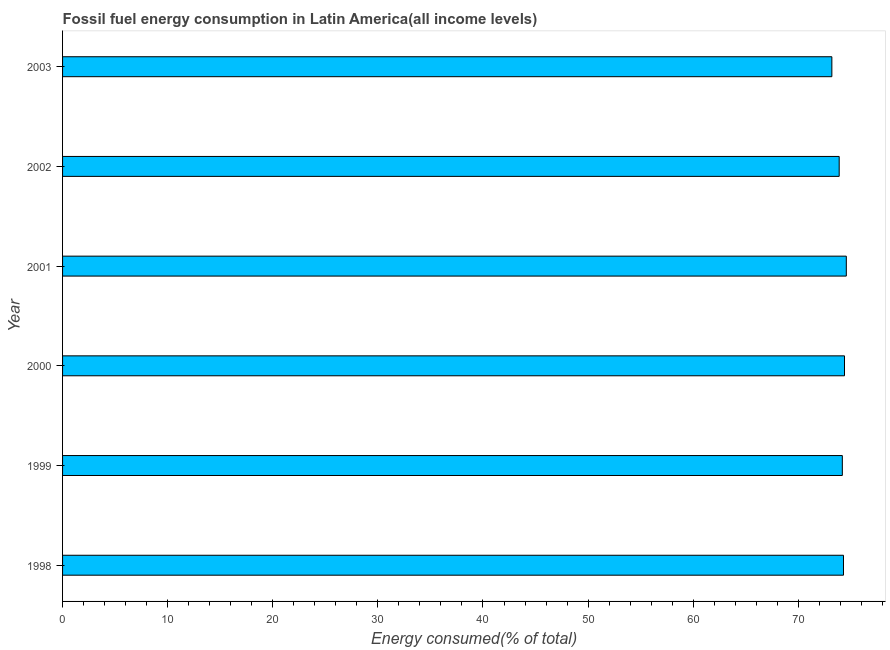Does the graph contain grids?
Your response must be concise. No. What is the title of the graph?
Your answer should be very brief. Fossil fuel energy consumption in Latin America(all income levels). What is the label or title of the X-axis?
Ensure brevity in your answer.  Energy consumed(% of total). What is the fossil fuel energy consumption in 2003?
Make the answer very short. 73.19. Across all years, what is the maximum fossil fuel energy consumption?
Provide a short and direct response. 74.57. Across all years, what is the minimum fossil fuel energy consumption?
Your answer should be very brief. 73.19. In which year was the fossil fuel energy consumption maximum?
Keep it short and to the point. 2001. In which year was the fossil fuel energy consumption minimum?
Your answer should be compact. 2003. What is the sum of the fossil fuel energy consumption?
Provide a succinct answer. 444.54. What is the difference between the fossil fuel energy consumption in 2002 and 2003?
Ensure brevity in your answer.  0.7. What is the average fossil fuel energy consumption per year?
Your response must be concise. 74.09. What is the median fossil fuel energy consumption?
Your response must be concise. 74.25. In how many years, is the fossil fuel energy consumption greater than 28 %?
Ensure brevity in your answer.  6. Do a majority of the years between 2002 and 2000 (inclusive) have fossil fuel energy consumption greater than 74 %?
Your answer should be compact. Yes. What is the ratio of the fossil fuel energy consumption in 1998 to that in 2001?
Offer a very short reply. 1. Is the fossil fuel energy consumption in 2000 less than that in 2001?
Provide a short and direct response. Yes. Is the difference between the fossil fuel energy consumption in 2000 and 2001 greater than the difference between any two years?
Provide a succinct answer. No. What is the difference between the highest and the second highest fossil fuel energy consumption?
Give a very brief answer. 0.17. Is the sum of the fossil fuel energy consumption in 1998 and 1999 greater than the maximum fossil fuel energy consumption across all years?
Make the answer very short. Yes. What is the difference between the highest and the lowest fossil fuel energy consumption?
Provide a succinct answer. 1.37. How many bars are there?
Make the answer very short. 6. Are all the bars in the graph horizontal?
Your answer should be very brief. Yes. How many years are there in the graph?
Your answer should be very brief. 6. What is the difference between two consecutive major ticks on the X-axis?
Make the answer very short. 10. Are the values on the major ticks of X-axis written in scientific E-notation?
Make the answer very short. No. What is the Energy consumed(% of total) in 1998?
Provide a succinct answer. 74.3. What is the Energy consumed(% of total) in 1999?
Ensure brevity in your answer.  74.19. What is the Energy consumed(% of total) of 2000?
Offer a very short reply. 74.4. What is the Energy consumed(% of total) of 2001?
Offer a very short reply. 74.57. What is the Energy consumed(% of total) in 2002?
Offer a terse response. 73.89. What is the Energy consumed(% of total) of 2003?
Offer a very short reply. 73.19. What is the difference between the Energy consumed(% of total) in 1998 and 1999?
Your response must be concise. 0.11. What is the difference between the Energy consumed(% of total) in 1998 and 2000?
Give a very brief answer. -0.1. What is the difference between the Energy consumed(% of total) in 1998 and 2001?
Make the answer very short. -0.27. What is the difference between the Energy consumed(% of total) in 1998 and 2002?
Keep it short and to the point. 0.41. What is the difference between the Energy consumed(% of total) in 1998 and 2003?
Provide a short and direct response. 1.11. What is the difference between the Energy consumed(% of total) in 1999 and 2000?
Make the answer very short. -0.21. What is the difference between the Energy consumed(% of total) in 1999 and 2001?
Give a very brief answer. -0.38. What is the difference between the Energy consumed(% of total) in 1999 and 2002?
Make the answer very short. 0.3. What is the difference between the Energy consumed(% of total) in 1999 and 2003?
Make the answer very short. 1. What is the difference between the Energy consumed(% of total) in 2000 and 2001?
Offer a very short reply. -0.17. What is the difference between the Energy consumed(% of total) in 2000 and 2002?
Make the answer very short. 0.51. What is the difference between the Energy consumed(% of total) in 2000 and 2003?
Offer a terse response. 1.2. What is the difference between the Energy consumed(% of total) in 2001 and 2002?
Offer a very short reply. 0.68. What is the difference between the Energy consumed(% of total) in 2001 and 2003?
Your answer should be very brief. 1.37. What is the difference between the Energy consumed(% of total) in 2002 and 2003?
Your response must be concise. 0.7. What is the ratio of the Energy consumed(% of total) in 1998 to that in 1999?
Make the answer very short. 1. What is the ratio of the Energy consumed(% of total) in 1998 to that in 2000?
Give a very brief answer. 1. What is the ratio of the Energy consumed(% of total) in 1998 to that in 2002?
Your answer should be compact. 1.01. What is the ratio of the Energy consumed(% of total) in 1998 to that in 2003?
Your answer should be compact. 1.01. What is the ratio of the Energy consumed(% of total) in 1999 to that in 2000?
Your answer should be compact. 1. What is the ratio of the Energy consumed(% of total) in 1999 to that in 2001?
Offer a very short reply. 0.99. What is the ratio of the Energy consumed(% of total) in 1999 to that in 2002?
Your answer should be very brief. 1. What is the ratio of the Energy consumed(% of total) in 2001 to that in 2002?
Your answer should be compact. 1.01. What is the ratio of the Energy consumed(% of total) in 2001 to that in 2003?
Your answer should be very brief. 1.02. 